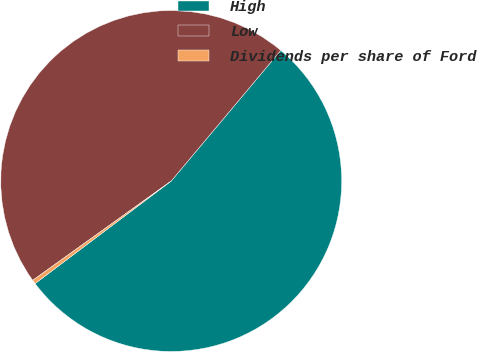<chart> <loc_0><loc_0><loc_500><loc_500><pie_chart><fcel>High<fcel>Low<fcel>Dividends per share of Ford<nl><fcel>53.61%<fcel>46.01%<fcel>0.38%<nl></chart> 